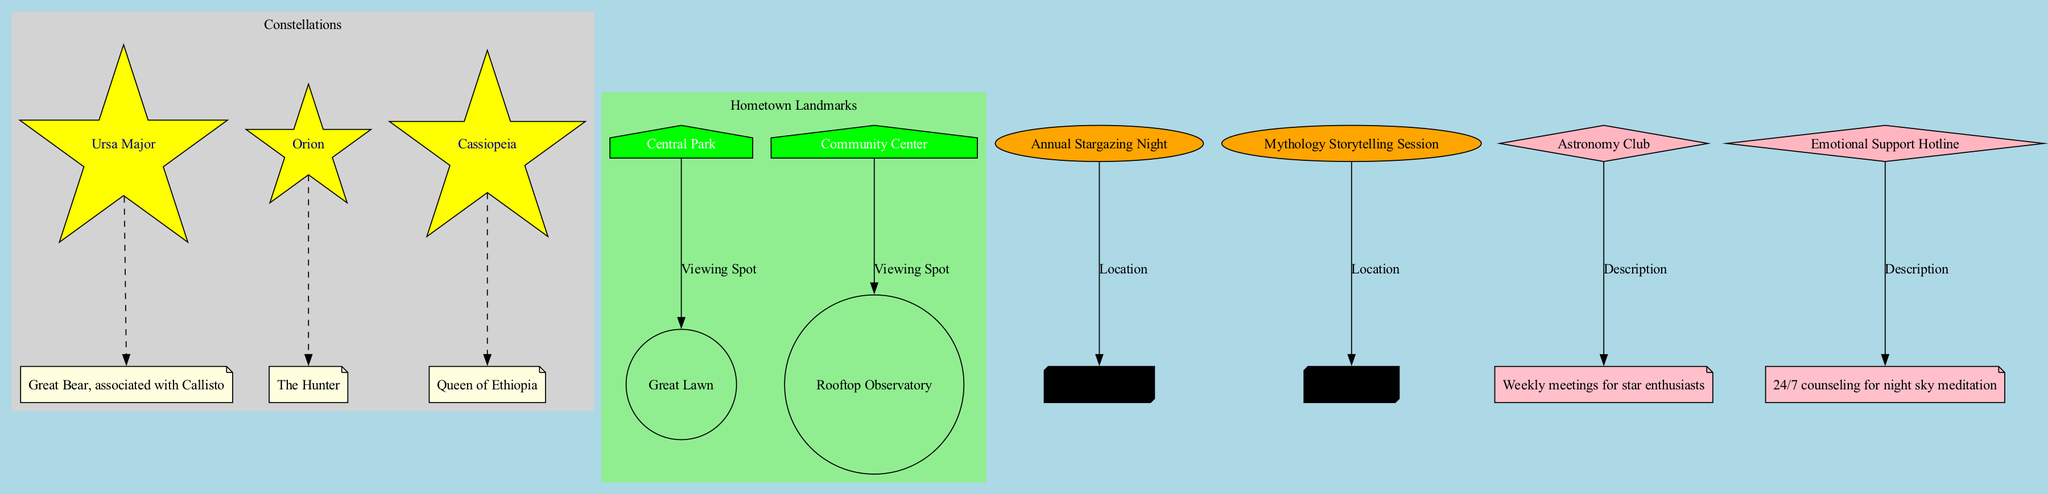What is the mythological connection of Orion? The node representing Orion connects directly to its mythological connection labeled 'The Hunter'. Since it is indicated clearly in the diagram, we can see that Orion is associated with this mythological aspect.
Answer: The Hunter How many hometown landmarks are shown in the diagram? The diagram contains two nodes that represent the hometown landmarks: 'Central Park' and 'Community Center'. Counting these nodes gives us the total number of landmarks displayed.
Answer: 2 Where is the viewing spot for Cassiopeia? The diagram shows 'Cassiopeia' connected to its viewing spot via a dashed edge. However, Cassiopeia itself does not have a direct viewing spot listed. The structured layout of the diagram suggests that constellation nodes do not have direct viewing spots like landmarks do.
Answer: None What is the location of the Annual Stargazing Night event? The 'Annual Stargazing Night' node is directly connected to the 'City Observatory' node by an edge labeled 'Location'. This direct connection shows that the event occurs at that specific location.
Answer: City Observatory Which support resource is related to the night sky meditation? In the support resources section, the node identified as 'Emotional Support Hotline' is designated for '24/7 counseling for night sky meditation'. The edge connecting these nodes makes it clear which resource relates to this form of support.
Answer: Emotional Support Hotline How many edges connect constellations to their mythological connections? Each constellation node—Ursa Major, Orion, and Cassiopeia—has an associated edge connecting it to its respective mythological connection. Counting these edges gives us the total connections from constellations to mythology.
Answer: 3 What is the viewing spot for Community Center? The diagram provides a connection from the 'Community Center' node to its viewing spot labeled 'Rooftop Observatory', showcasing the designated area for viewing.
Answer: Rooftop Observatory Which event takes place at the Public Library? The node 'Mythology Storytelling Session' is connected by an edge to the 'Public Library' node, indicating the event's location. This delineation provides a clear understanding of where this event occurs.
Answer: Public Library 